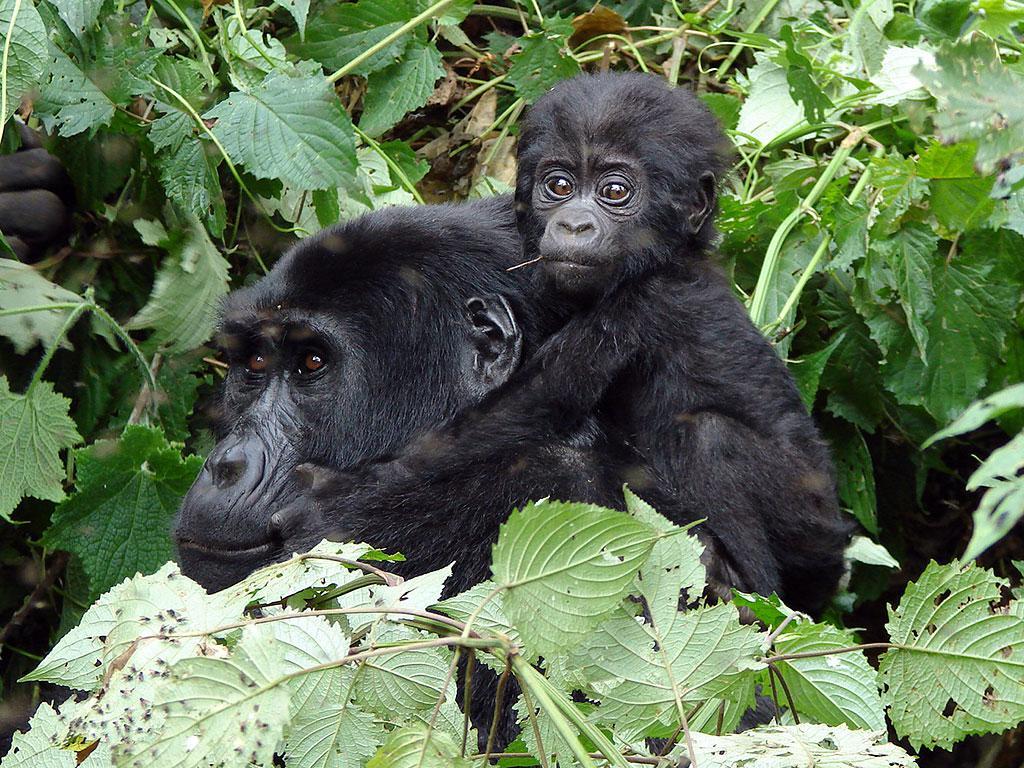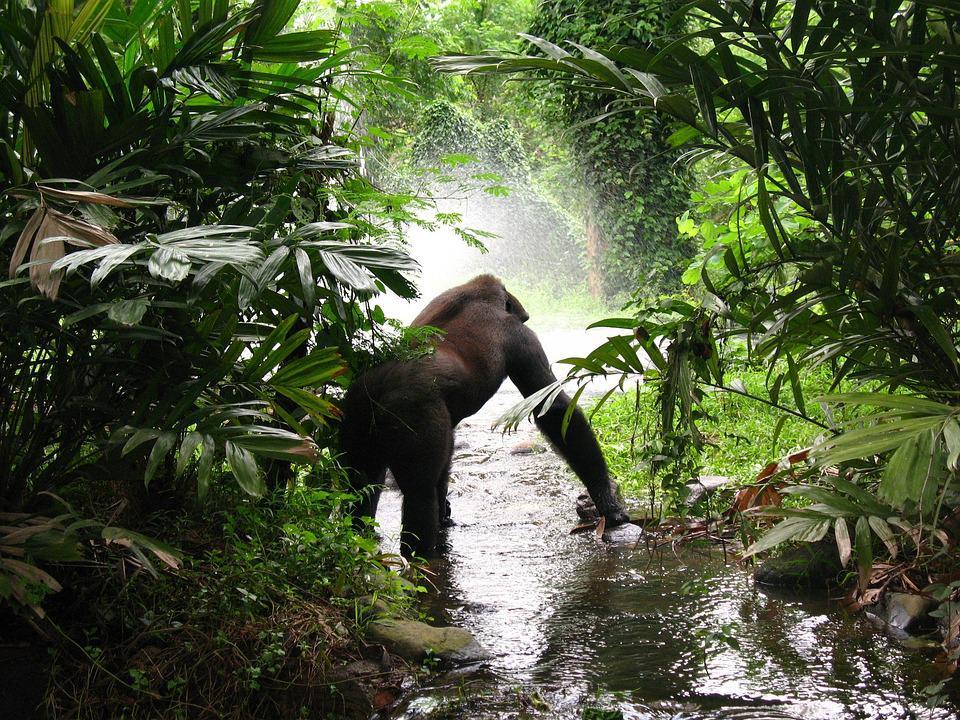The first image is the image on the left, the second image is the image on the right. Considering the images on both sides, is "The left image includes a rear-facing adult gorilla on all fours, with its body turned rightward and smaller gorillas around it." valid? Answer yes or no. No. The first image is the image on the left, the second image is the image on the right. Considering the images on both sides, is "The right image contains no more than one gorilla." valid? Answer yes or no. Yes. 